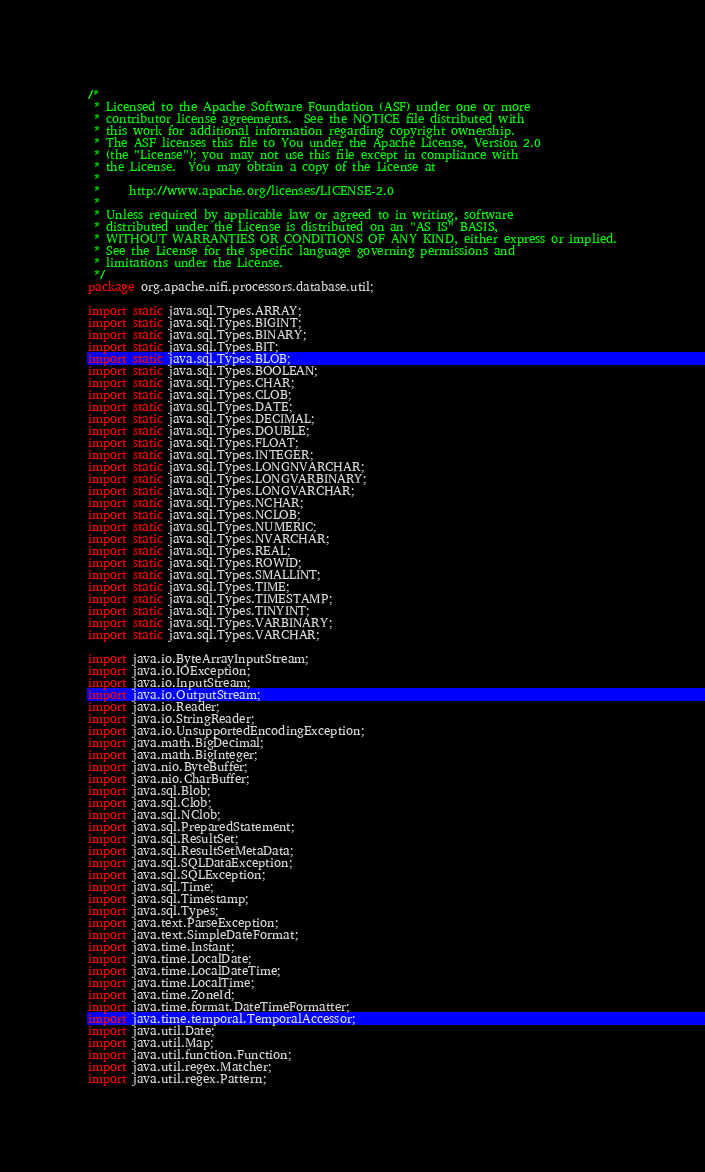<code> <loc_0><loc_0><loc_500><loc_500><_Java_>/*
 * Licensed to the Apache Software Foundation (ASF) under one or more
 * contributor license agreements.  See the NOTICE file distributed with
 * this work for additional information regarding copyright ownership.
 * The ASF licenses this file to You under the Apache License, Version 2.0
 * (the "License"); you may not use this file except in compliance with
 * the License.  You may obtain a copy of the License at
 *
 *     http://www.apache.org/licenses/LICENSE-2.0
 *
 * Unless required by applicable law or agreed to in writing, software
 * distributed under the License is distributed on an "AS IS" BASIS,
 * WITHOUT WARRANTIES OR CONDITIONS OF ANY KIND, either express or implied.
 * See the License for the specific language governing permissions and
 * limitations under the License.
 */
package org.apache.nifi.processors.database.util;

import static java.sql.Types.ARRAY;
import static java.sql.Types.BIGINT;
import static java.sql.Types.BINARY;
import static java.sql.Types.BIT;
import static java.sql.Types.BLOB;
import static java.sql.Types.BOOLEAN;
import static java.sql.Types.CHAR;
import static java.sql.Types.CLOB;
import static java.sql.Types.DATE;
import static java.sql.Types.DECIMAL;
import static java.sql.Types.DOUBLE;
import static java.sql.Types.FLOAT;
import static java.sql.Types.INTEGER;
import static java.sql.Types.LONGNVARCHAR;
import static java.sql.Types.LONGVARBINARY;
import static java.sql.Types.LONGVARCHAR;
import static java.sql.Types.NCHAR;
import static java.sql.Types.NCLOB;
import static java.sql.Types.NUMERIC;
import static java.sql.Types.NVARCHAR;
import static java.sql.Types.REAL;
import static java.sql.Types.ROWID;
import static java.sql.Types.SMALLINT;
import static java.sql.Types.TIME;
import static java.sql.Types.TIMESTAMP;
import static java.sql.Types.TINYINT;
import static java.sql.Types.VARBINARY;
import static java.sql.Types.VARCHAR;

import java.io.ByteArrayInputStream;
import java.io.IOException;
import java.io.InputStream;
import java.io.OutputStream;
import java.io.Reader;
import java.io.StringReader;
import java.io.UnsupportedEncodingException;
import java.math.BigDecimal;
import java.math.BigInteger;
import java.nio.ByteBuffer;
import java.nio.CharBuffer;
import java.sql.Blob;
import java.sql.Clob;
import java.sql.NClob;
import java.sql.PreparedStatement;
import java.sql.ResultSet;
import java.sql.ResultSetMetaData;
import java.sql.SQLDataException;
import java.sql.SQLException;
import java.sql.Time;
import java.sql.Timestamp;
import java.sql.Types;
import java.text.ParseException;
import java.text.SimpleDateFormat;
import java.time.Instant;
import java.time.LocalDate;
import java.time.LocalDateTime;
import java.time.LocalTime;
import java.time.ZoneId;
import java.time.format.DateTimeFormatter;
import java.time.temporal.TemporalAccessor;
import java.util.Date;
import java.util.Map;
import java.util.function.Function;
import java.util.regex.Matcher;
import java.util.regex.Pattern;
</code> 